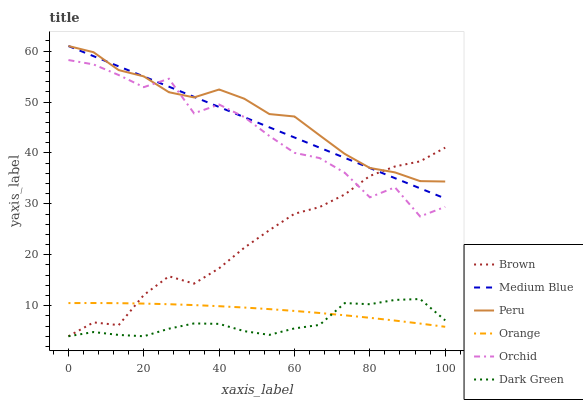Does Dark Green have the minimum area under the curve?
Answer yes or no. Yes. Does Peru have the maximum area under the curve?
Answer yes or no. Yes. Does Medium Blue have the minimum area under the curve?
Answer yes or no. No. Does Medium Blue have the maximum area under the curve?
Answer yes or no. No. Is Medium Blue the smoothest?
Answer yes or no. Yes. Is Orchid the roughest?
Answer yes or no. Yes. Is Peru the smoothest?
Answer yes or no. No. Is Peru the roughest?
Answer yes or no. No. Does Brown have the lowest value?
Answer yes or no. Yes. Does Medium Blue have the lowest value?
Answer yes or no. No. Does Peru have the highest value?
Answer yes or no. Yes. Does Orange have the highest value?
Answer yes or no. No. Is Orange less than Orchid?
Answer yes or no. Yes. Is Peru greater than Dark Green?
Answer yes or no. Yes. Does Medium Blue intersect Peru?
Answer yes or no. Yes. Is Medium Blue less than Peru?
Answer yes or no. No. Is Medium Blue greater than Peru?
Answer yes or no. No. Does Orange intersect Orchid?
Answer yes or no. No. 